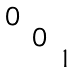<formula> <loc_0><loc_0><loc_500><loc_500>\begin{smallmatrix} 0 & & \\ & 0 & \\ & & 1 \end{smallmatrix}</formula> 